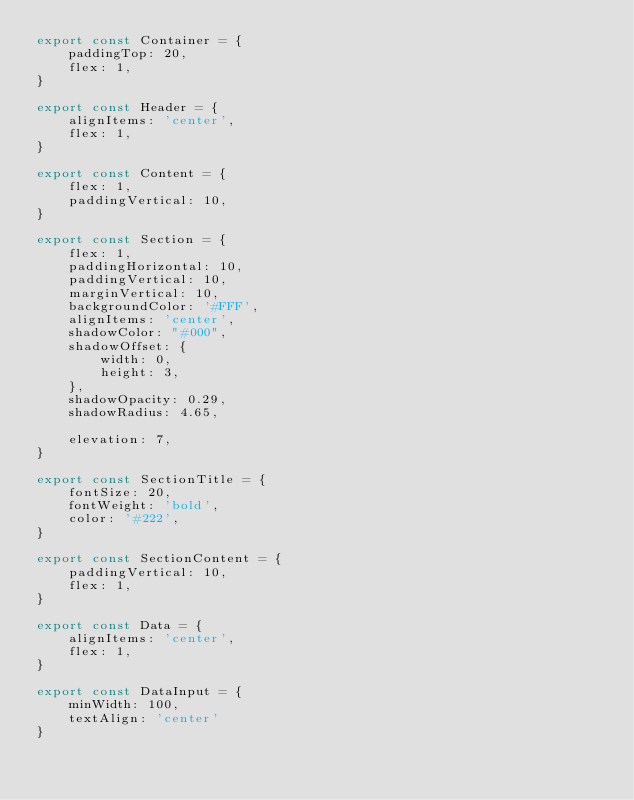Convert code to text. <code><loc_0><loc_0><loc_500><loc_500><_JavaScript_>export const Container = {
    paddingTop: 20,
    flex: 1,
}

export const Header = {
    alignItems: 'center',
    flex: 1,
}

export const Content = {
    flex: 1,
    paddingVertical: 10,
}

export const Section = {
    flex: 1,
    paddingHorizontal: 10,
    paddingVertical: 10,
    marginVertical: 10,
    backgroundColor: '#FFF',
    alignItems: 'center',
    shadowColor: "#000",
    shadowOffset: {
        width: 0,
        height: 3,
    },
    shadowOpacity: 0.29,
    shadowRadius: 4.65,
    
    elevation: 7,
}

export const SectionTitle = {
    fontSize: 20,
    fontWeight: 'bold',
    color: '#222',
}

export const SectionContent = {
    paddingVertical: 10,
    flex: 1,
}

export const Data = {
    alignItems: 'center',
    flex: 1,
}

export const DataInput = {
    minWidth: 100,
    textAlign: 'center'
}
</code> 